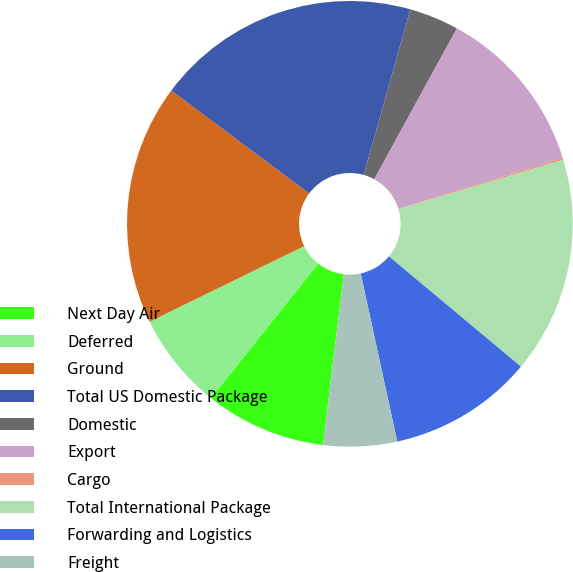Convert chart to OTSL. <chart><loc_0><loc_0><loc_500><loc_500><pie_chart><fcel>Next Day Air<fcel>Deferred<fcel>Ground<fcel>Total US Domestic Package<fcel>Domestic<fcel>Export<fcel>Cargo<fcel>Total International Package<fcel>Forwarding and Logistics<fcel>Freight<nl><fcel>8.79%<fcel>7.06%<fcel>17.44%<fcel>19.17%<fcel>3.6%<fcel>12.25%<fcel>0.14%<fcel>15.71%<fcel>10.52%<fcel>5.33%<nl></chart> 